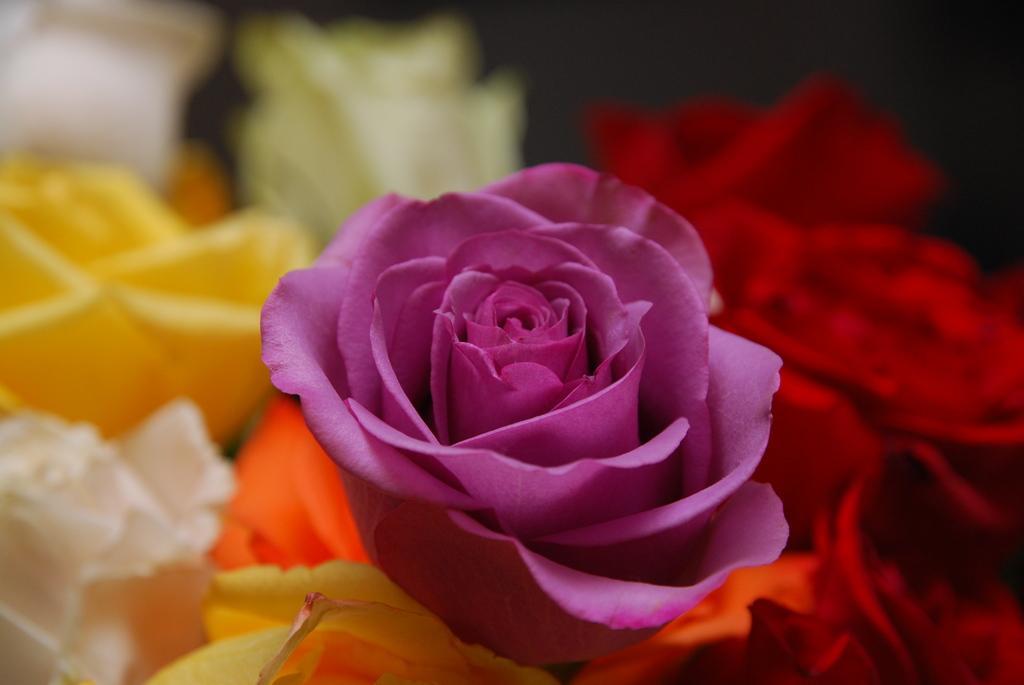In one or two sentences, can you explain what this image depicts? In this image we can see the beautiful flowers of different colors. 